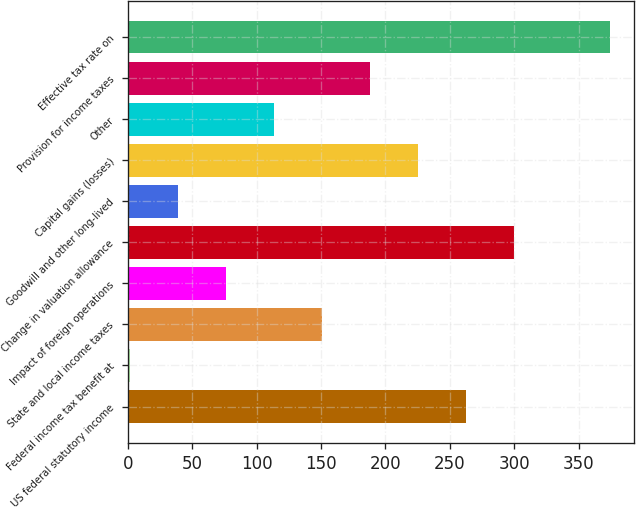<chart> <loc_0><loc_0><loc_500><loc_500><bar_chart><fcel>US federal statutory income<fcel>Federal income tax benefit at<fcel>State and local income taxes<fcel>Impact of foreign operations<fcel>Change in valuation allowance<fcel>Goodwill and other long-lived<fcel>Capital gains (losses)<fcel>Other<fcel>Provision for income taxes<fcel>Effective tax rate on<nl><fcel>262.34<fcel>1.8<fcel>150.68<fcel>76.24<fcel>299.56<fcel>39.02<fcel>225.12<fcel>113.46<fcel>187.9<fcel>374<nl></chart> 